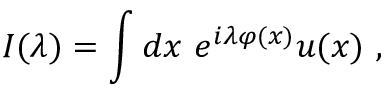Convert formula to latex. <formula><loc_0><loc_0><loc_500><loc_500>I ( \lambda ) = \int d x \, e ^ { i \lambda \varphi ( x ) } u ( x ) \, ,</formula> 